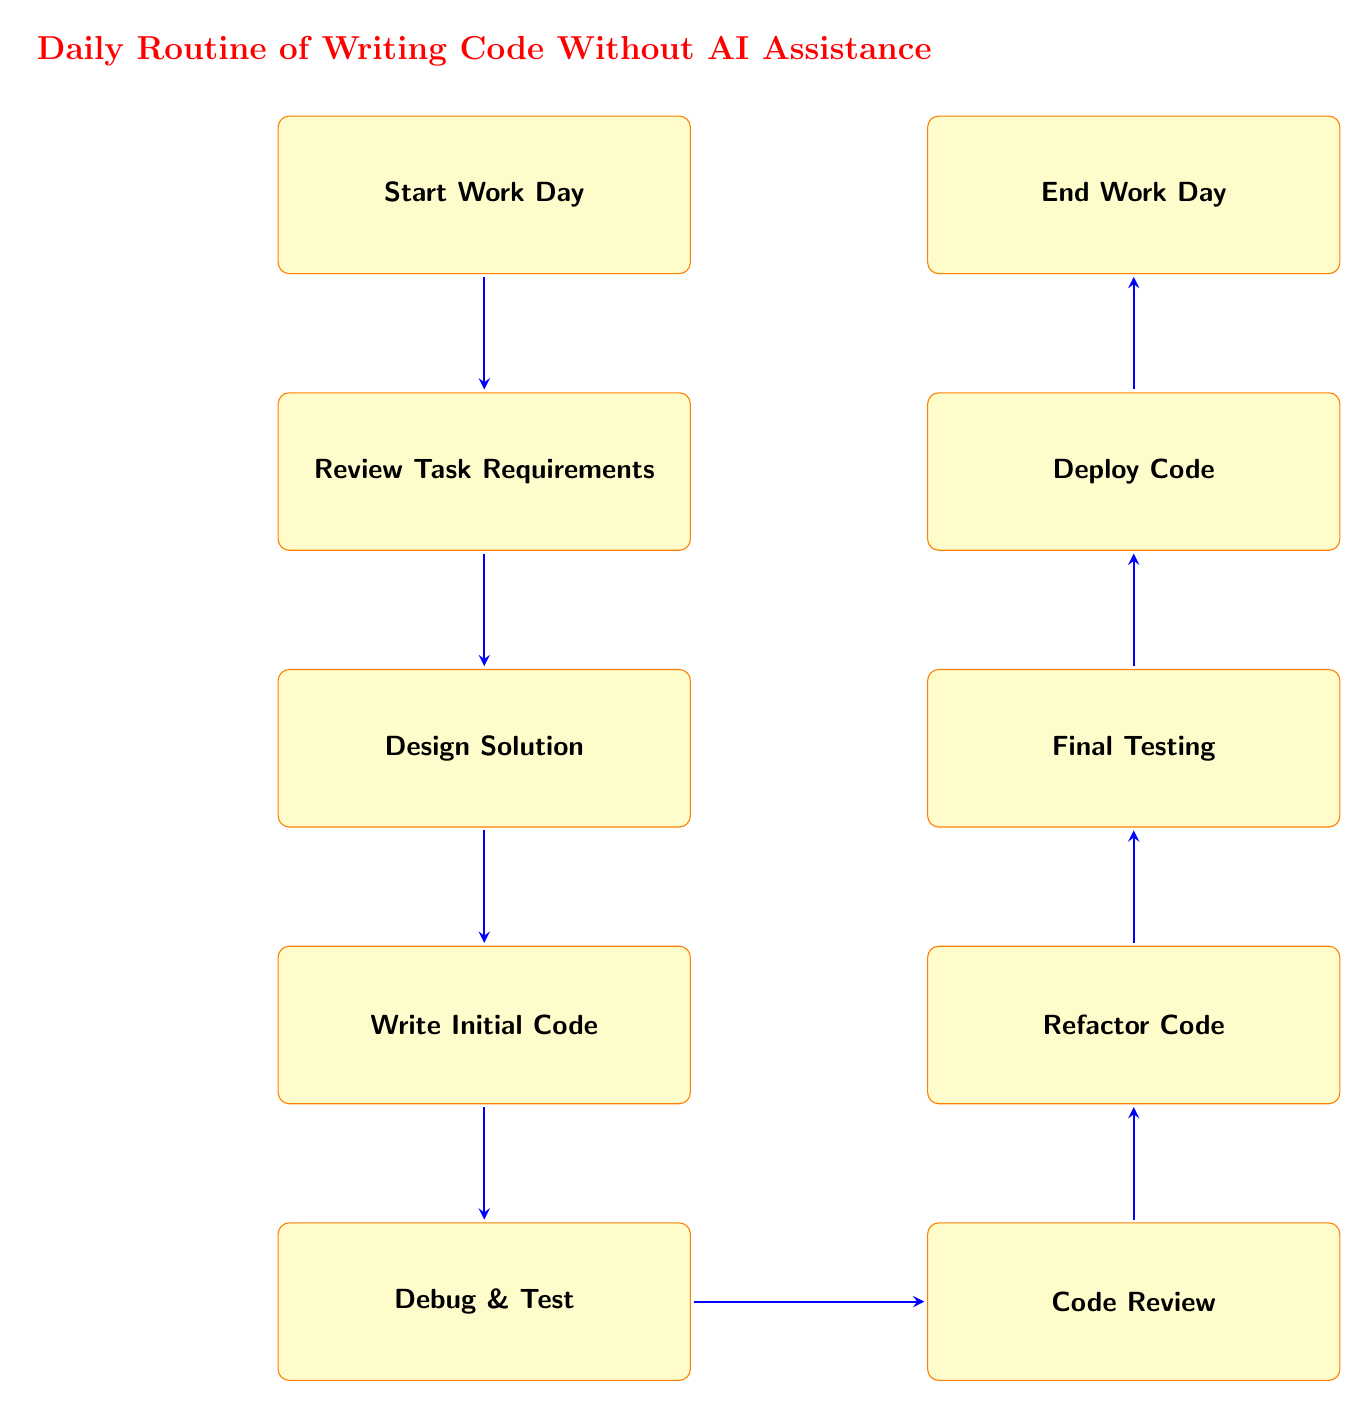What is the first step in the flow chart? The first step in the flow chart is labeled "Start Work Day," as it is the initial node before any other actions.
Answer: Start Work Day How many nodes are in the flow chart? The flow chart contains ten nodes, each representing a specific action in the daily coding routine.
Answer: Ten What follows "Debug & Test" in the flow chart? The node that follows "Debug & Test" is "Code Review," which indicates the next action after testing and debugging.
Answer: Code Review What is the last step in the daily coding routine? The last step in the flow chart is labeled "End Work Day," which signifies the conclusion of the daily tasks.
Answer: End Work Day Is "Review Task Requirements" connected to "Deploy Code"? No, "Review Task Requirements" is not connected directly to "Deploy Code"; there are multiple steps in between these two nodes.
Answer: No Which node comes immediately after "Write Initial Code"? The node that comes immediately after "Write Initial Code" is "Debug & Test," indicating what should be done next.
Answer: Debug & Test What two nodes are directly connected to "Refactor Code"? "Refactor Code" is directly connected to "Code Review" and "Final Testing," representing the flow from feedback to final testing.
Answer: Code Review and Final Testing What action does the flow chart suggest before deploying the code? Before deploying the code, the flow chart suggests performing "Final Testing" to ensure the robustness of the code.
Answer: Final Testing How many actions are taken before "Code Review"? Four actions are taken before "Code Review," which are "Start Work Day," "Review Task Requirements," "Design Solution," and "Write Initial Code."
Answer: Four 